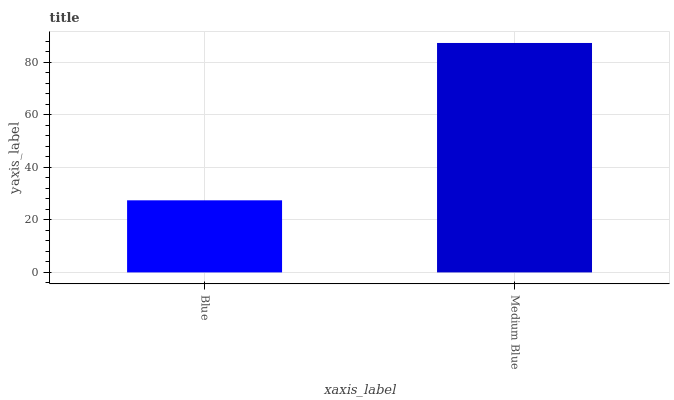Is Blue the minimum?
Answer yes or no. Yes. Is Medium Blue the maximum?
Answer yes or no. Yes. Is Medium Blue the minimum?
Answer yes or no. No. Is Medium Blue greater than Blue?
Answer yes or no. Yes. Is Blue less than Medium Blue?
Answer yes or no. Yes. Is Blue greater than Medium Blue?
Answer yes or no. No. Is Medium Blue less than Blue?
Answer yes or no. No. Is Medium Blue the high median?
Answer yes or no. Yes. Is Blue the low median?
Answer yes or no. Yes. Is Blue the high median?
Answer yes or no. No. Is Medium Blue the low median?
Answer yes or no. No. 